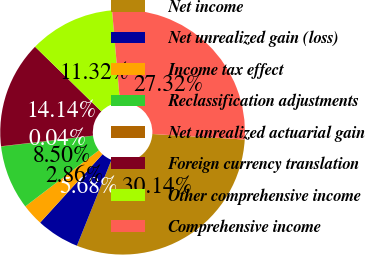<chart> <loc_0><loc_0><loc_500><loc_500><pie_chart><fcel>Net income<fcel>Net unrealized gain (loss)<fcel>Income tax effect<fcel>Reclassification adjustments<fcel>Net unrealized actuarial gain<fcel>Foreign currency translation<fcel>Other comprehensive income<fcel>Comprehensive income<nl><fcel>30.14%<fcel>5.68%<fcel>2.86%<fcel>8.5%<fcel>0.04%<fcel>14.14%<fcel>11.32%<fcel>27.32%<nl></chart> 